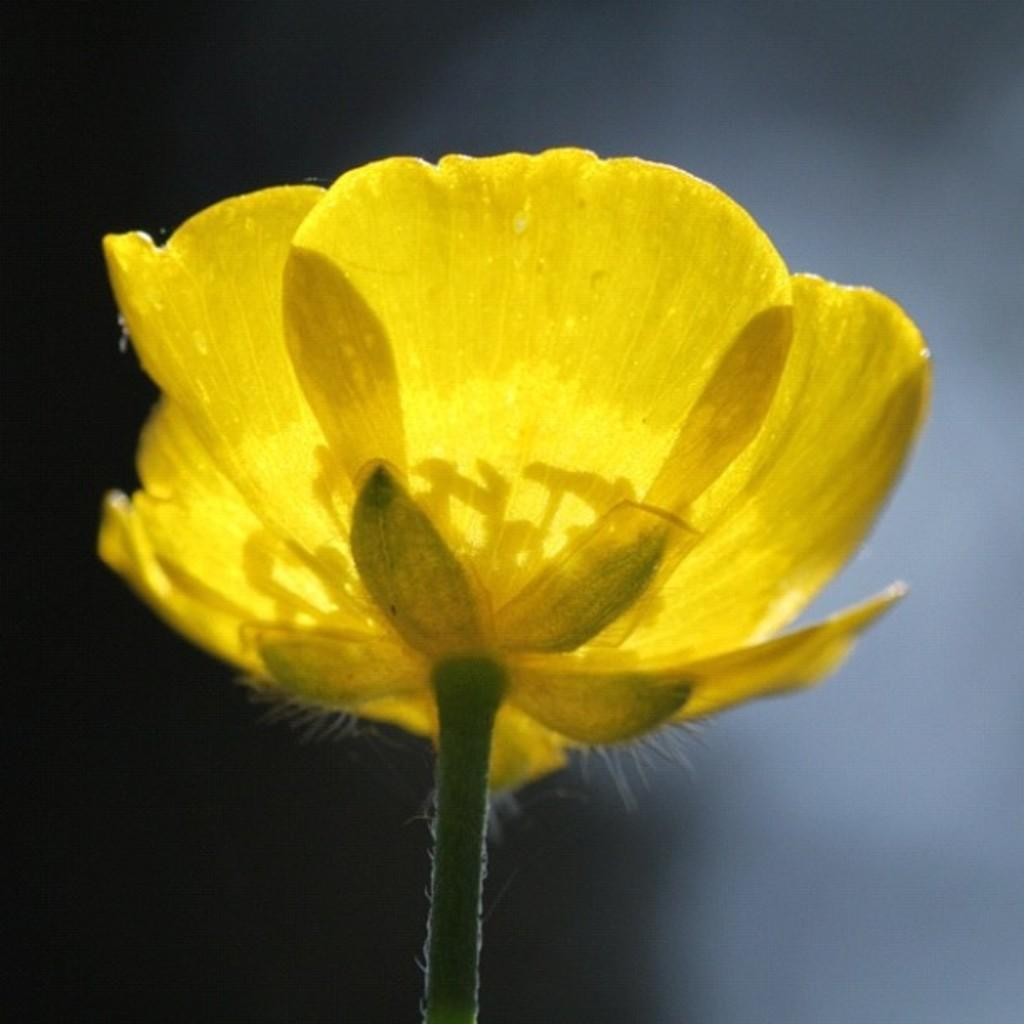What is the main subject in the foreground of the image? There is a yellow color flower in the foreground of the image. Can you describe the background of the image? The background of the image is blurred. What type of oven is visible in the image? There is no oven present in the image; it features a yellow color flower in the foreground and a blurred background. Can you tell me how many women are sneezing in the image? There are no women or sneezing depicted in the image. 